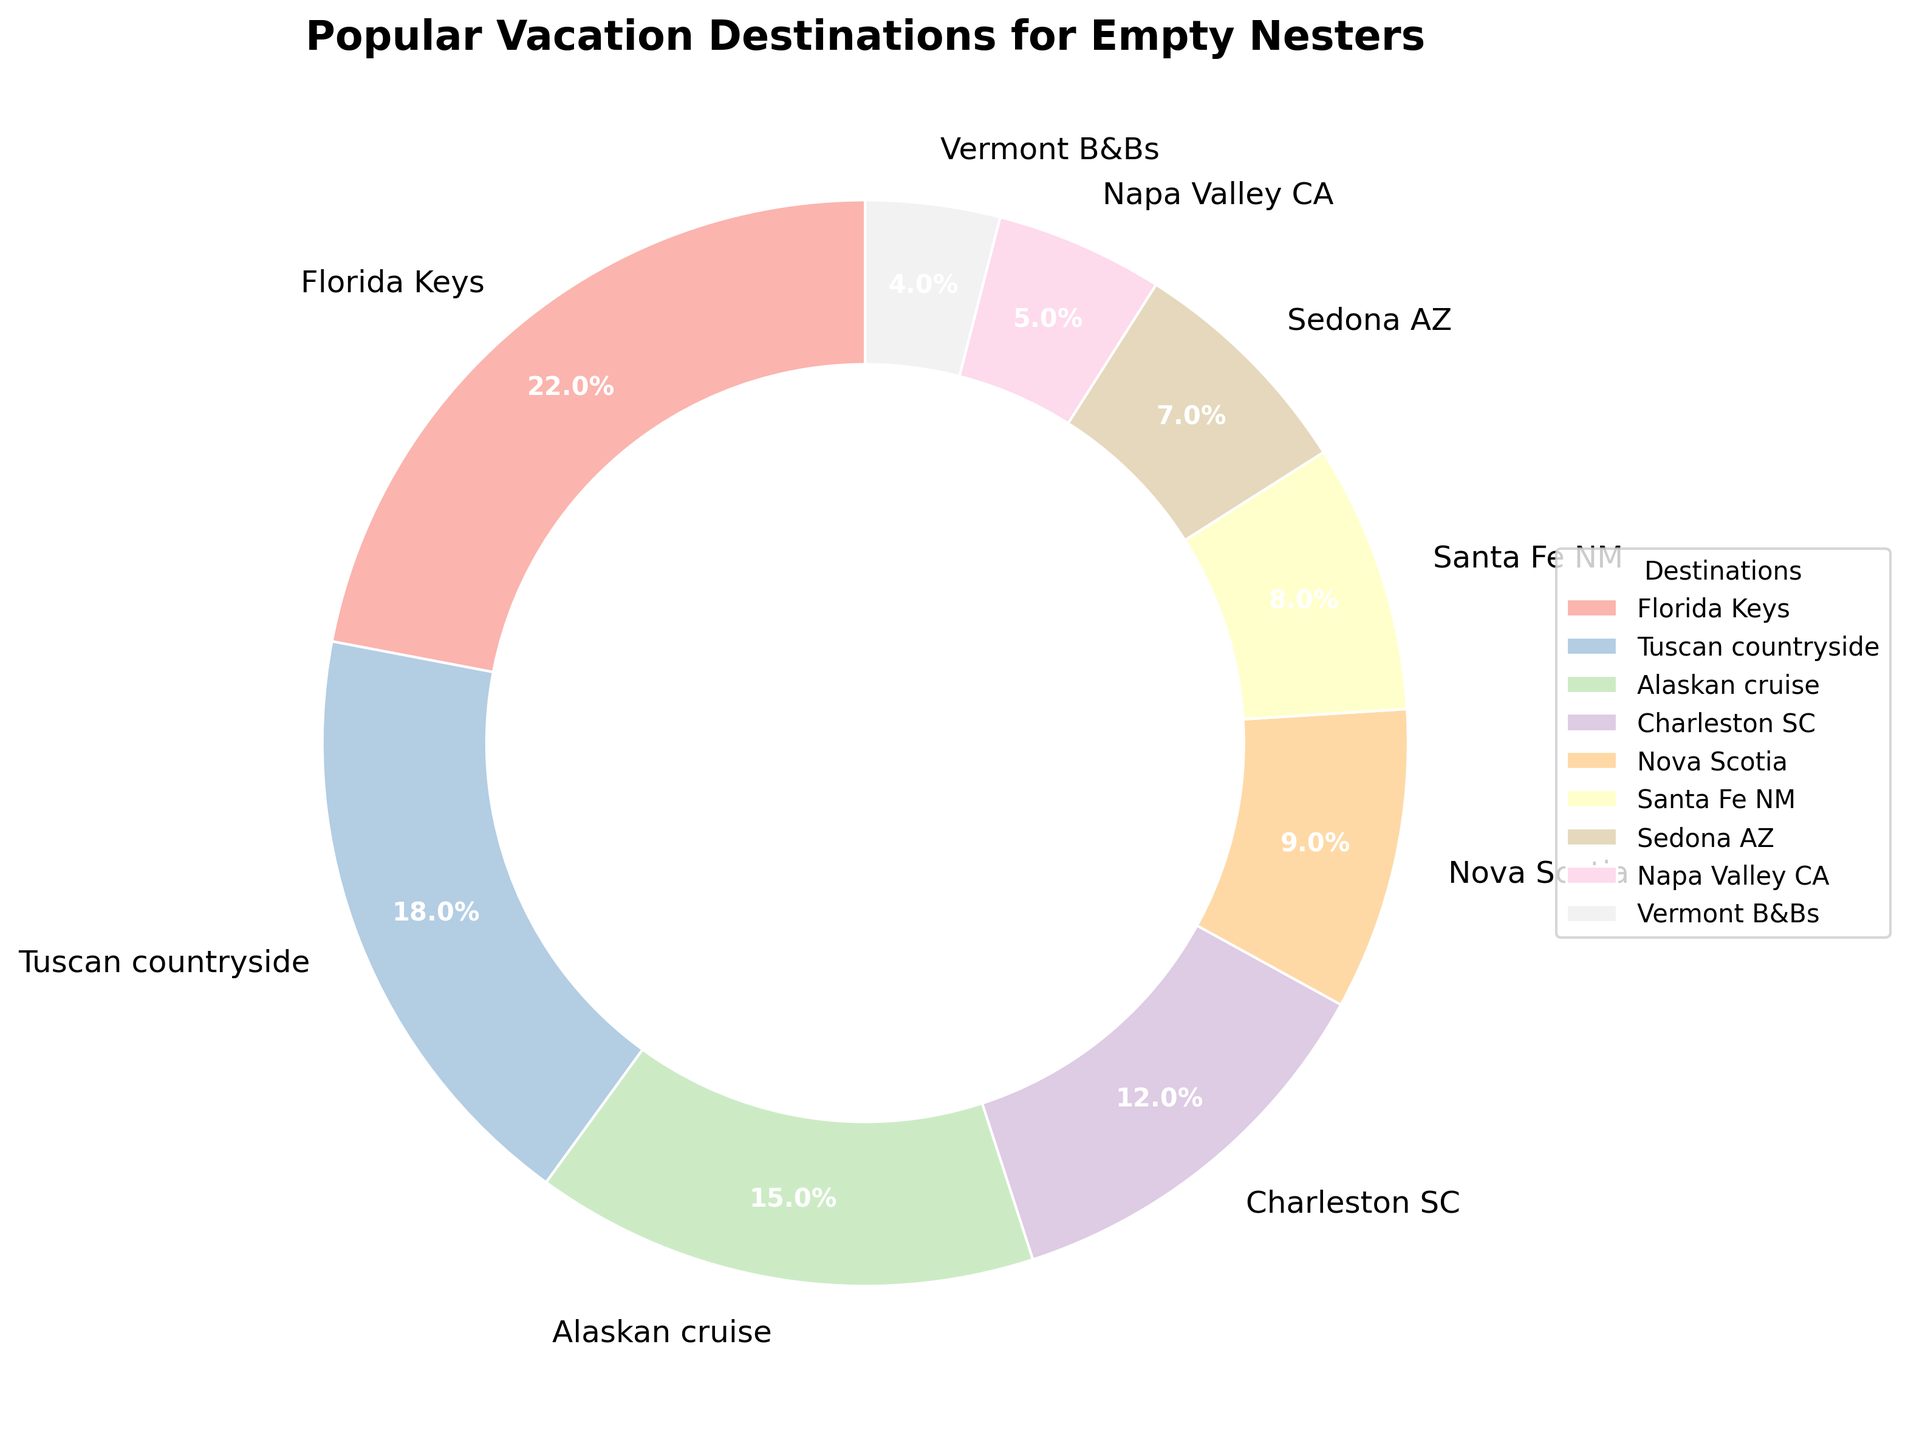Which destination has the highest percentage? In the chart, each slice is labeled with its destination and percentage. The Florida Keys has the largest slice with 22%.
Answer: Florida Keys What's the sum of the percentages for the Florida Keys and the Tuscan countryside? Add the percentages of the Florida Keys (22%) and the Tuscan countryside (18%). So, 22 + 18 = 40.
Answer: 40 Which two destinations have the closest percentages? Compare the percentages to find the smallest difference. Santa Fe NM (8%) and Sedona AZ (7%) have the smallest difference of 1%.
Answer: Santa Fe NM and Sedona AZ What is the difference in percentage between the Alaskan cruise and Charleston SC? Subtract the percentage of Charleston SC (12%) from the percentage of the Alaskan cruise (15%). So, 15 - 12 = 3.
Answer: 3 What is the total percentage represented by destinations in the southwestern United States (Santa Fe NM, Sedona AZ, and Napa Valley CA)? Sum the percentages of Santa Fe NM (8%), Sedona AZ (7%), and Napa Valley CA (5%). So, 8 + 7 + 5 = 20.
Answer: 20 Which destination in the Northeastern United States has the smallest percentage? Compare destinations in the Northeast. Vermont B&Bs have the smallest percentage at 4%.
Answer: Vermont B&Bs Are there more people going to Santa Fe NM or Nova Scotia? Compare the percentages of Santa Fe NM (8%) and Nova Scotia (9%). Nova Scotia has a higher percentage.
Answer: Nova Scotia What percentage of people prefer destinations with a percentage below 10%? Sum the percentages of Nova Scotia (9%), Santa Fe NM (8%), Sedona AZ (7%), Napa Valley CA (5%), and Vermont B&Bs (4%). So, 9 + 8 + 7 + 5 + 4 = 33.
Answer: 33 Which region (Florida Keys or Alaskan cruise) comprises a larger percentage of the vacation destinations? Compare the percentages of the Florida Keys (22%) and the Alaskan cruise (15%). The Florida Keys has a larger percentage.
Answer: Florida Keys 